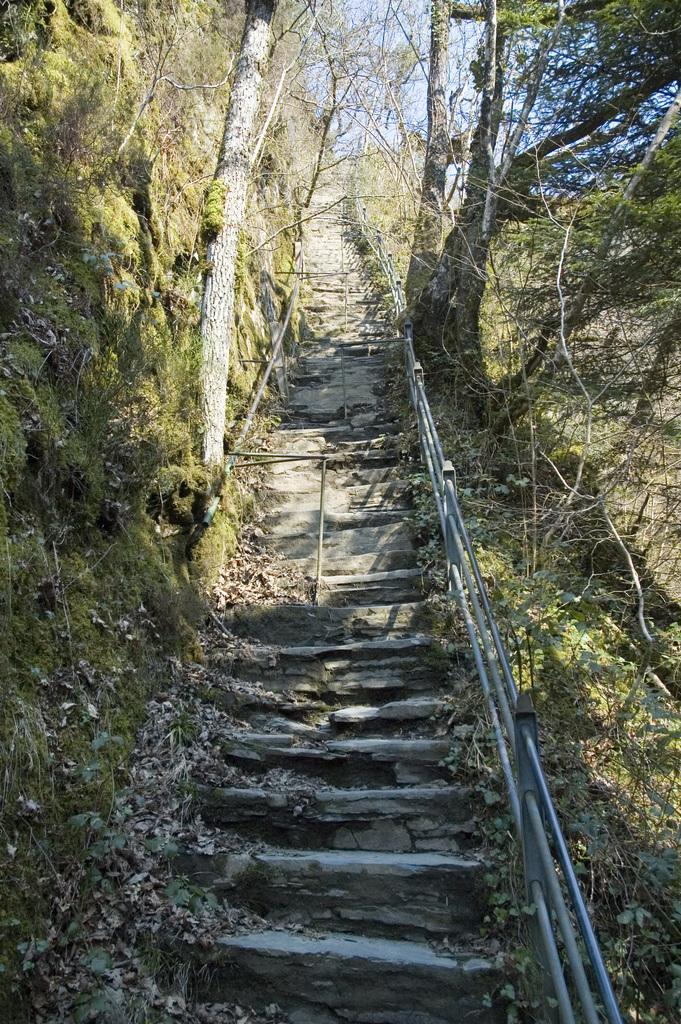In one or two sentences, can you explain what this image depicts? In this picture we can see steps, trees and in the background we can see the sky. 